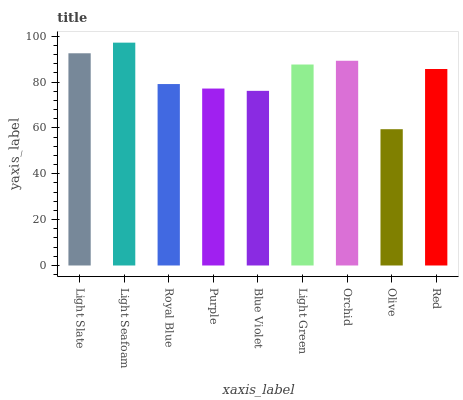Is Royal Blue the minimum?
Answer yes or no. No. Is Royal Blue the maximum?
Answer yes or no. No. Is Light Seafoam greater than Royal Blue?
Answer yes or no. Yes. Is Royal Blue less than Light Seafoam?
Answer yes or no. Yes. Is Royal Blue greater than Light Seafoam?
Answer yes or no. No. Is Light Seafoam less than Royal Blue?
Answer yes or no. No. Is Red the high median?
Answer yes or no. Yes. Is Red the low median?
Answer yes or no. Yes. Is Light Green the high median?
Answer yes or no. No. Is Blue Violet the low median?
Answer yes or no. No. 